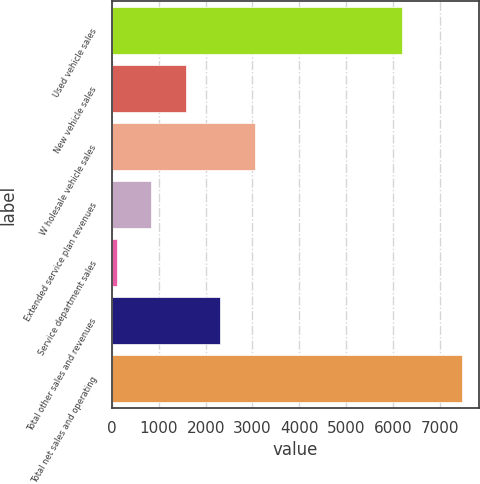Convert chart to OTSL. <chart><loc_0><loc_0><loc_500><loc_500><bar_chart><fcel>Used vehicle sales<fcel>New vehicle sales<fcel>W holesale vehicle sales<fcel>Extended service plan revenues<fcel>Service department sales<fcel>Total other sales and revenues<fcel>Total net sales and operating<nl><fcel>6192.3<fcel>1574.92<fcel>3048.74<fcel>838.01<fcel>101.1<fcel>2311.83<fcel>7470.2<nl></chart> 